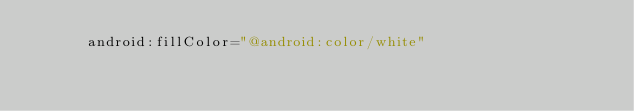Convert code to text. <code><loc_0><loc_0><loc_500><loc_500><_XML_>      android:fillColor="@android:color/white"</code> 